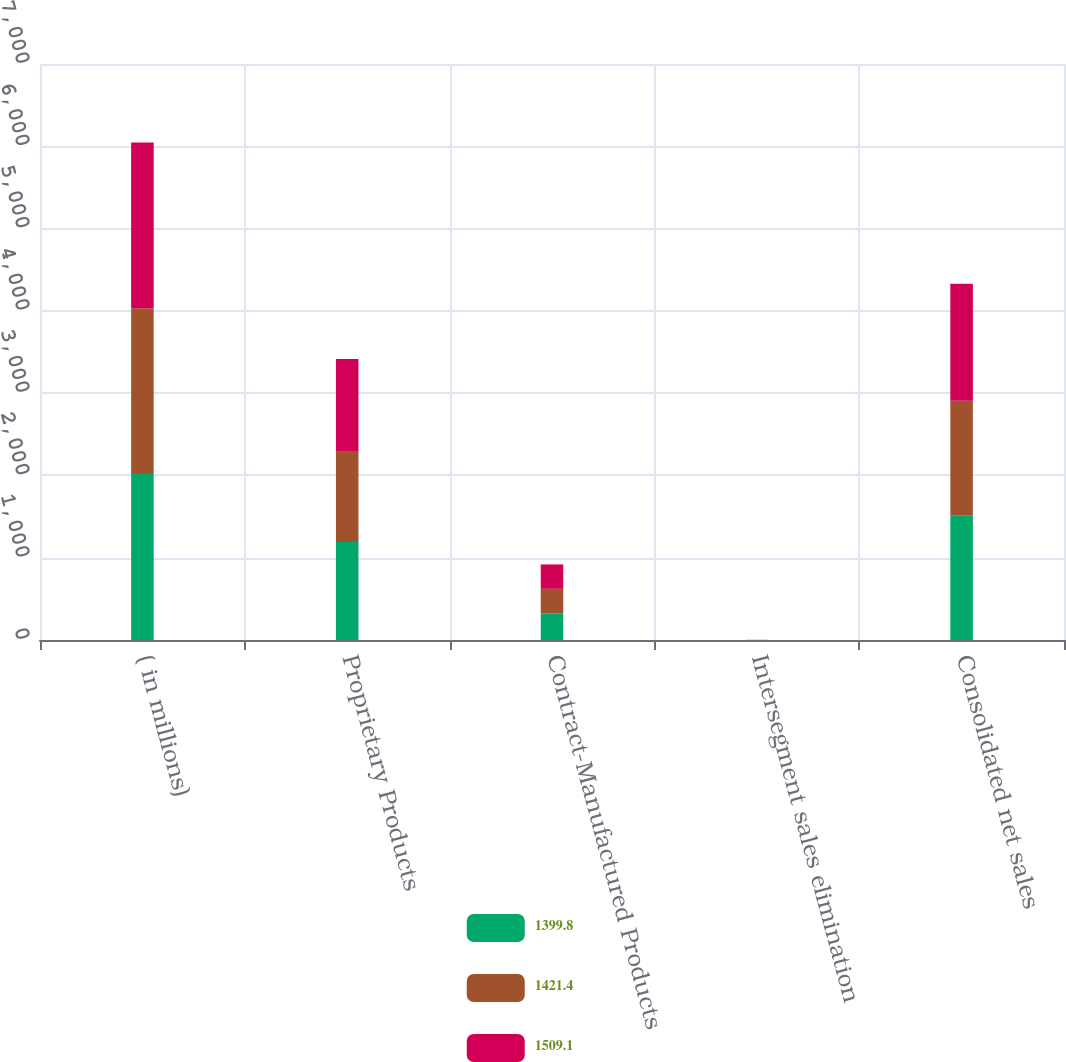<chart> <loc_0><loc_0><loc_500><loc_500><stacked_bar_chart><ecel><fcel>( in millions)<fcel>Proprietary Products<fcel>Contract-Manufactured Products<fcel>Intersegment sales elimination<fcel>Consolidated net sales<nl><fcel>1399.8<fcel>2016<fcel>1189.9<fcel>320.2<fcel>1<fcel>1509.1<nl><fcel>1421.4<fcel>2015<fcel>1098.3<fcel>302.4<fcel>0.9<fcel>1399.8<nl><fcel>1509.1<fcel>2014<fcel>1126.3<fcel>295.7<fcel>0.6<fcel>1421.4<nl></chart> 